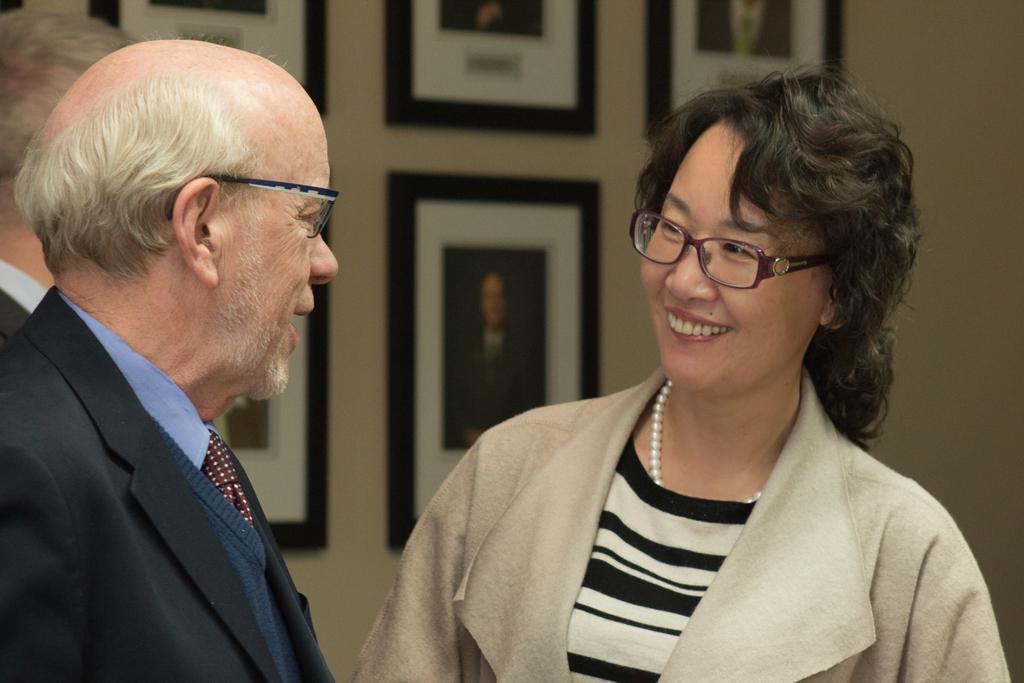In one or two sentences, can you explain what this image depicts? In this picture I can see few people standing and I can see few photo frames on the wall and couple of them wore spectacles. 